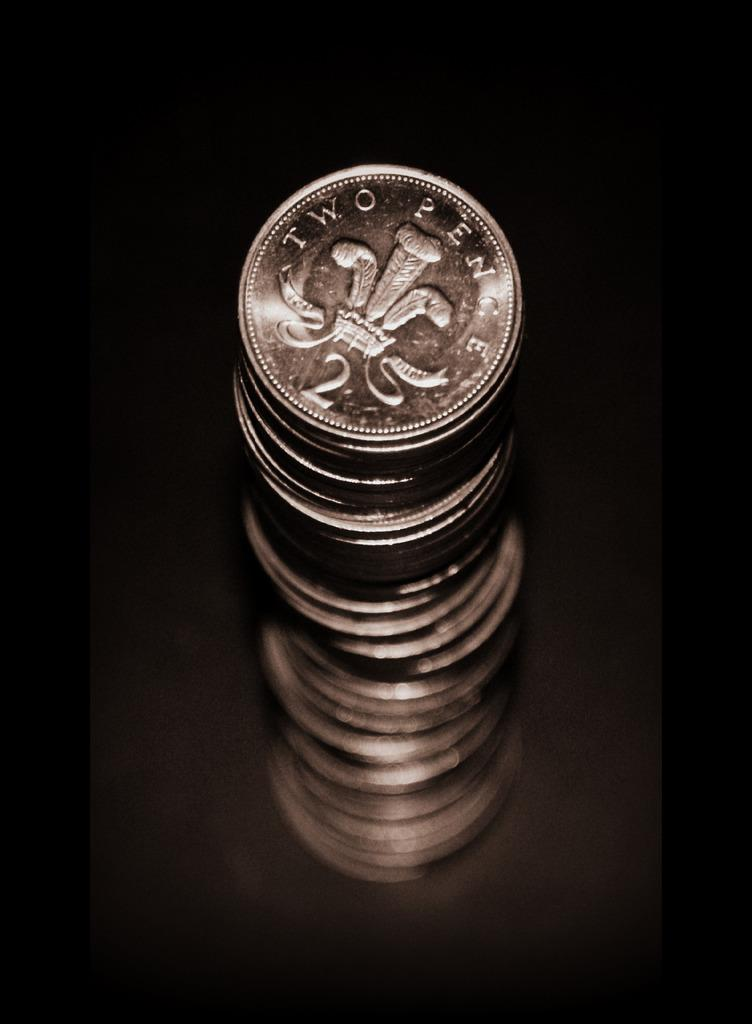<image>
Present a compact description of the photo's key features. A tall stack of silver coins with two pence written on them. 